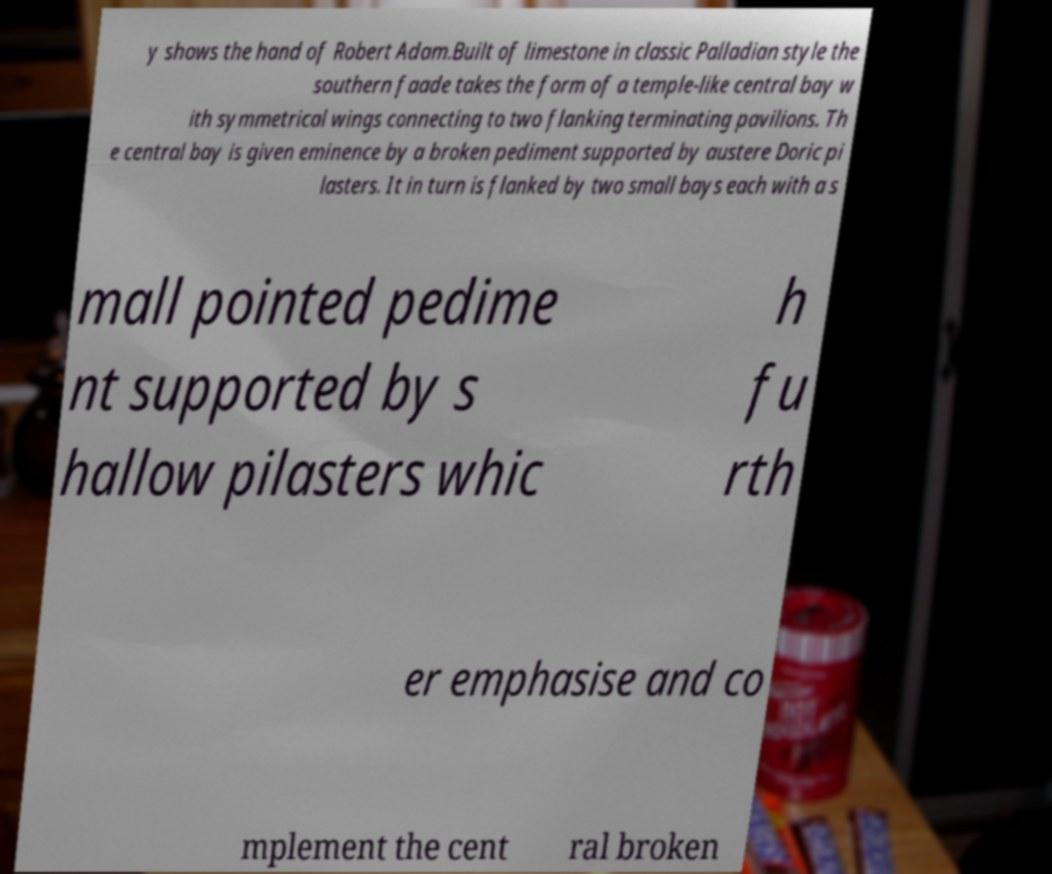Please read and relay the text visible in this image. What does it say? y shows the hand of Robert Adam.Built of limestone in classic Palladian style the southern faade takes the form of a temple-like central bay w ith symmetrical wings connecting to two flanking terminating pavilions. Th e central bay is given eminence by a broken pediment supported by austere Doric pi lasters. It in turn is flanked by two small bays each with a s mall pointed pedime nt supported by s hallow pilasters whic h fu rth er emphasise and co mplement the cent ral broken 